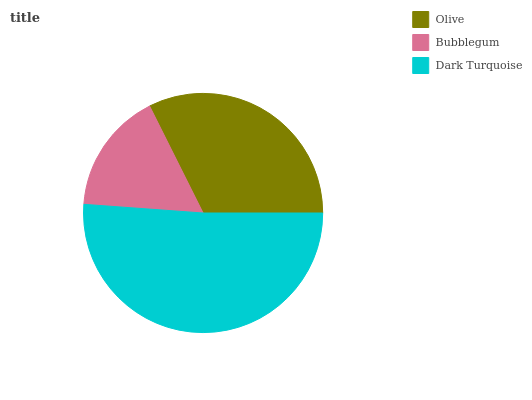Is Bubblegum the minimum?
Answer yes or no. Yes. Is Dark Turquoise the maximum?
Answer yes or no. Yes. Is Dark Turquoise the minimum?
Answer yes or no. No. Is Bubblegum the maximum?
Answer yes or no. No. Is Dark Turquoise greater than Bubblegum?
Answer yes or no. Yes. Is Bubblegum less than Dark Turquoise?
Answer yes or no. Yes. Is Bubblegum greater than Dark Turquoise?
Answer yes or no. No. Is Dark Turquoise less than Bubblegum?
Answer yes or no. No. Is Olive the high median?
Answer yes or no. Yes. Is Olive the low median?
Answer yes or no. Yes. Is Bubblegum the high median?
Answer yes or no. No. Is Bubblegum the low median?
Answer yes or no. No. 